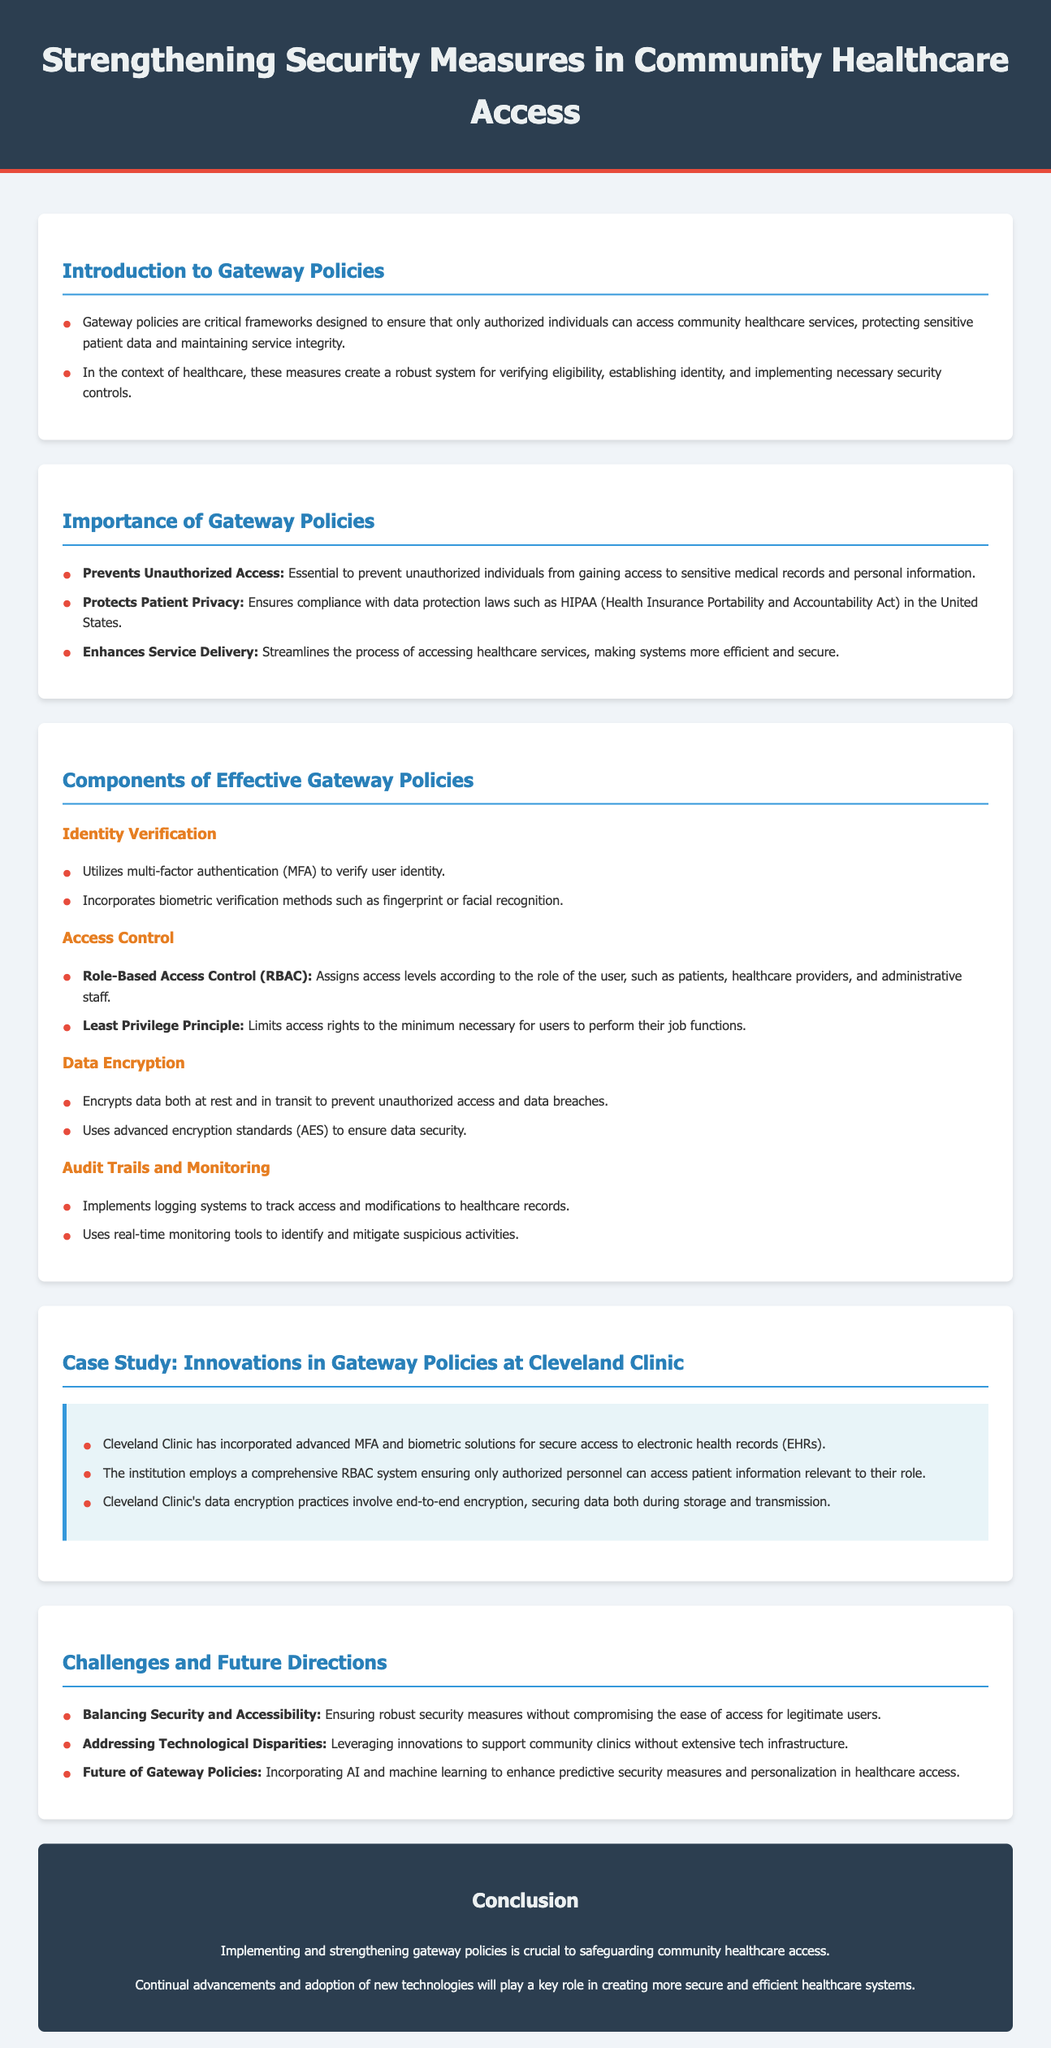What are gateway policies? Gateway policies are critical frameworks designed to ensure that only authorized individuals can access community healthcare services, protecting sensitive patient data and maintaining service integrity.
Answer: Critical frameworks What is the purpose of role-based access control (RBAC)? RBAC assigns access levels according to the role of the user, such as patients, healthcare providers, and administrative staff.
Answer: Assigns access levels What does MFA stand for? MFA stands for multi-factor authentication, used to verify user identity.
Answer: Multi-factor authentication What technology does Cleveland Clinic use for secure access to electronic health records? Cleveland Clinic has incorporated advanced MFA and biometric solutions for secure access.
Answer: MFA and biometric solutions What is a challenge mentioned in the document regarding gateway policies? A challenge is balancing security and accessibility, ensuring robustness without compromising ease of access.
Answer: Balancing security and accessibility How does the document refer to protecting patient data? It refers to ensuring compliance with data protection laws such as HIPAA.
Answer: Compliance with data protection laws How is data encrypted according to the document? Data is encrypted both at rest and in transit to prevent unauthorized access and data breaches.
Answer: Both at rest and in transit What emerging technologies are mentioned for the future of gateway policies? The document mentions incorporating AI and machine learning to enhance security measures.
Answer: AI and machine learning 